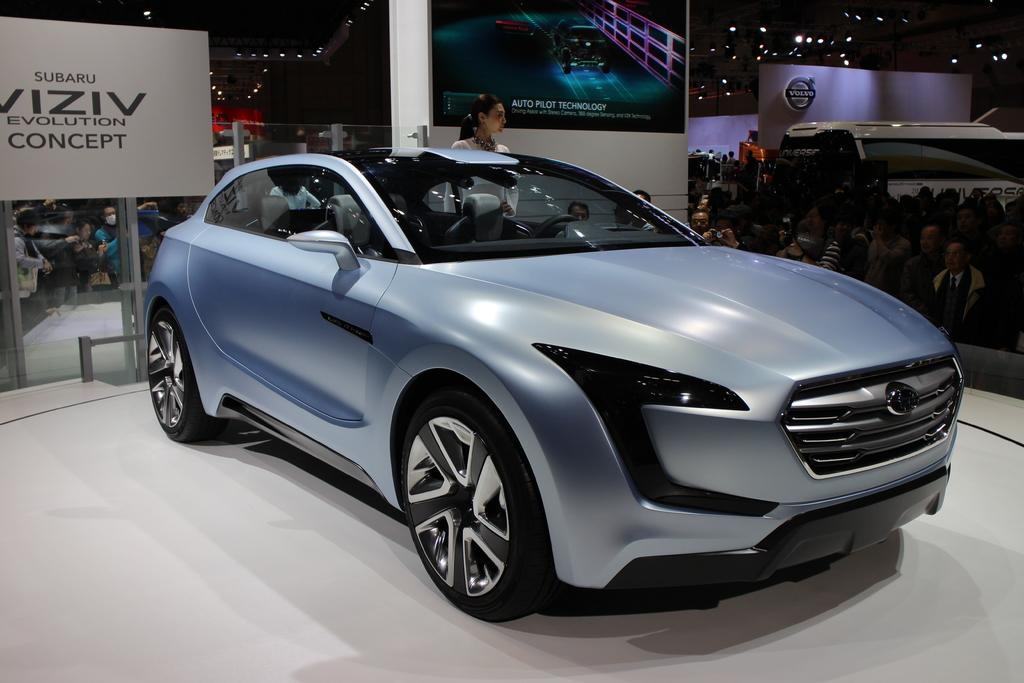What is the main subject in the center of the image? There is a car in the center of the image. Can you describe the position of the car in the image? The car is on the ground in the image. What can be seen in the background of the image? In the background of the image, there are persons, advertisements, a logo, lights, and a wall. How does the needle increase the power of the car in the image? There is no needle present in the image, and therefore no such interaction can be observed. 